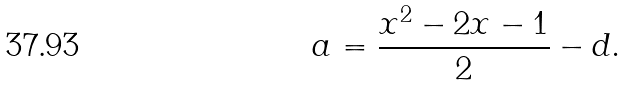Convert formula to latex. <formula><loc_0><loc_0><loc_500><loc_500>a = \frac { x ^ { 2 } - 2 x - 1 } { 2 } - d .</formula> 